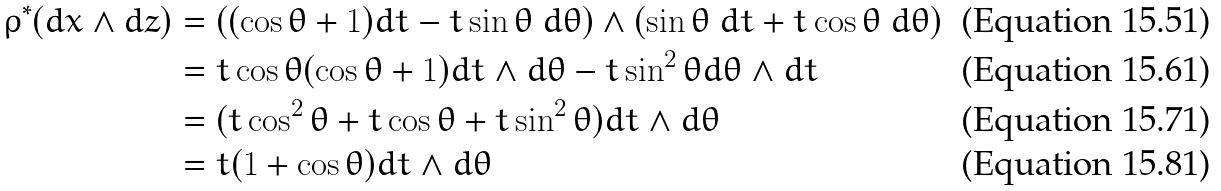<formula> <loc_0><loc_0><loc_500><loc_500>\rho ^ { * } ( d x \wedge d z ) & = ( ( \cos \theta + 1 ) d t - t \sin \theta \ d \theta ) \wedge ( \sin \theta \ d t + t \cos \theta \ d \theta ) \\ & = t \cos \theta ( \cos \theta + 1 ) d t \wedge d \theta - t \sin ^ { 2 } \theta d \theta \wedge d t \\ & = ( t \cos ^ { 2 } \theta + t \cos \theta + t \sin ^ { 2 } \theta ) d t \wedge d \theta \\ & = t ( 1 + \cos \theta ) d t \wedge d \theta</formula> 